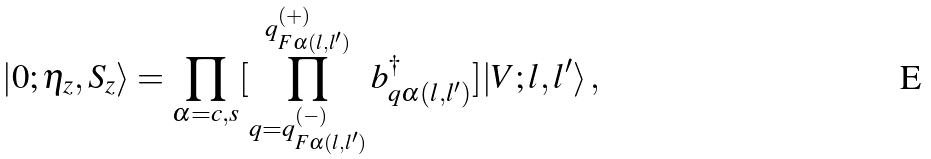<formula> <loc_0><loc_0><loc_500><loc_500>| 0 ; \eta _ { z } , S _ { z } \rangle = \prod _ { \alpha = c , s } [ \prod _ { q = q _ { F \alpha ( l , l ^ { \prime } ) } ^ { ( - ) } } ^ { q _ { F \alpha ( l , l ^ { \prime } ) } ^ { ( + ) } } b ^ { \dag } _ { q \alpha ( l , l ^ { \prime } ) } ] | V ; l , l ^ { \prime } \rangle \, ,</formula> 